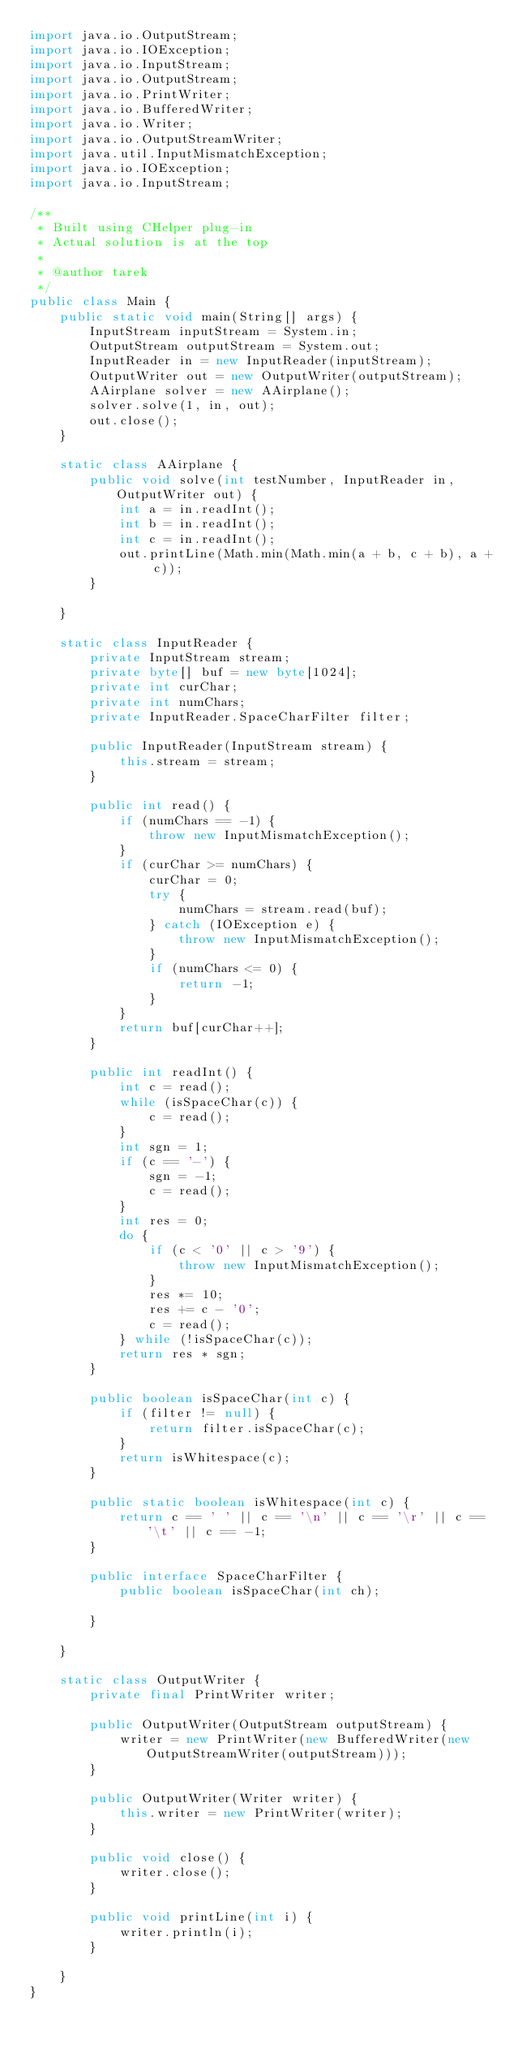Convert code to text. <code><loc_0><loc_0><loc_500><loc_500><_Java_>import java.io.OutputStream;
import java.io.IOException;
import java.io.InputStream;
import java.io.OutputStream;
import java.io.PrintWriter;
import java.io.BufferedWriter;
import java.io.Writer;
import java.io.OutputStreamWriter;
import java.util.InputMismatchException;
import java.io.IOException;
import java.io.InputStream;

/**
 * Built using CHelper plug-in
 * Actual solution is at the top
 *
 * @author tarek
 */
public class Main {
    public static void main(String[] args) {
        InputStream inputStream = System.in;
        OutputStream outputStream = System.out;
        InputReader in = new InputReader(inputStream);
        OutputWriter out = new OutputWriter(outputStream);
        AAirplane solver = new AAirplane();
        solver.solve(1, in, out);
        out.close();
    }

    static class AAirplane {
        public void solve(int testNumber, InputReader in, OutputWriter out) {
            int a = in.readInt();
            int b = in.readInt();
            int c = in.readInt();
            out.printLine(Math.min(Math.min(a + b, c + b), a + c));
        }

    }

    static class InputReader {
        private InputStream stream;
        private byte[] buf = new byte[1024];
        private int curChar;
        private int numChars;
        private InputReader.SpaceCharFilter filter;

        public InputReader(InputStream stream) {
            this.stream = stream;
        }

        public int read() {
            if (numChars == -1) {
                throw new InputMismatchException();
            }
            if (curChar >= numChars) {
                curChar = 0;
                try {
                    numChars = stream.read(buf);
                } catch (IOException e) {
                    throw new InputMismatchException();
                }
                if (numChars <= 0) {
                    return -1;
                }
            }
            return buf[curChar++];
        }

        public int readInt() {
            int c = read();
            while (isSpaceChar(c)) {
                c = read();
            }
            int sgn = 1;
            if (c == '-') {
                sgn = -1;
                c = read();
            }
            int res = 0;
            do {
                if (c < '0' || c > '9') {
                    throw new InputMismatchException();
                }
                res *= 10;
                res += c - '0';
                c = read();
            } while (!isSpaceChar(c));
            return res * sgn;
        }

        public boolean isSpaceChar(int c) {
            if (filter != null) {
                return filter.isSpaceChar(c);
            }
            return isWhitespace(c);
        }

        public static boolean isWhitespace(int c) {
            return c == ' ' || c == '\n' || c == '\r' || c == '\t' || c == -1;
        }

        public interface SpaceCharFilter {
            public boolean isSpaceChar(int ch);

        }

    }

    static class OutputWriter {
        private final PrintWriter writer;

        public OutputWriter(OutputStream outputStream) {
            writer = new PrintWriter(new BufferedWriter(new OutputStreamWriter(outputStream)));
        }

        public OutputWriter(Writer writer) {
            this.writer = new PrintWriter(writer);
        }

        public void close() {
            writer.close();
        }

        public void printLine(int i) {
            writer.println(i);
        }

    }
}

</code> 